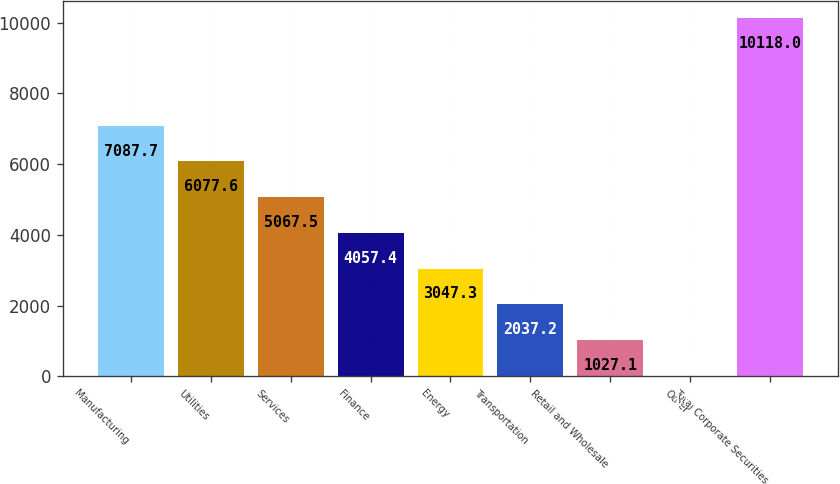Convert chart to OTSL. <chart><loc_0><loc_0><loc_500><loc_500><bar_chart><fcel>Manufacturing<fcel>Utilities<fcel>Services<fcel>Finance<fcel>Energy<fcel>Transportation<fcel>Retail and Wholesale<fcel>Other<fcel>Total Corporate Securities<nl><fcel>7087.7<fcel>6077.6<fcel>5067.5<fcel>4057.4<fcel>3047.3<fcel>2037.2<fcel>1027.1<fcel>17<fcel>10118<nl></chart> 